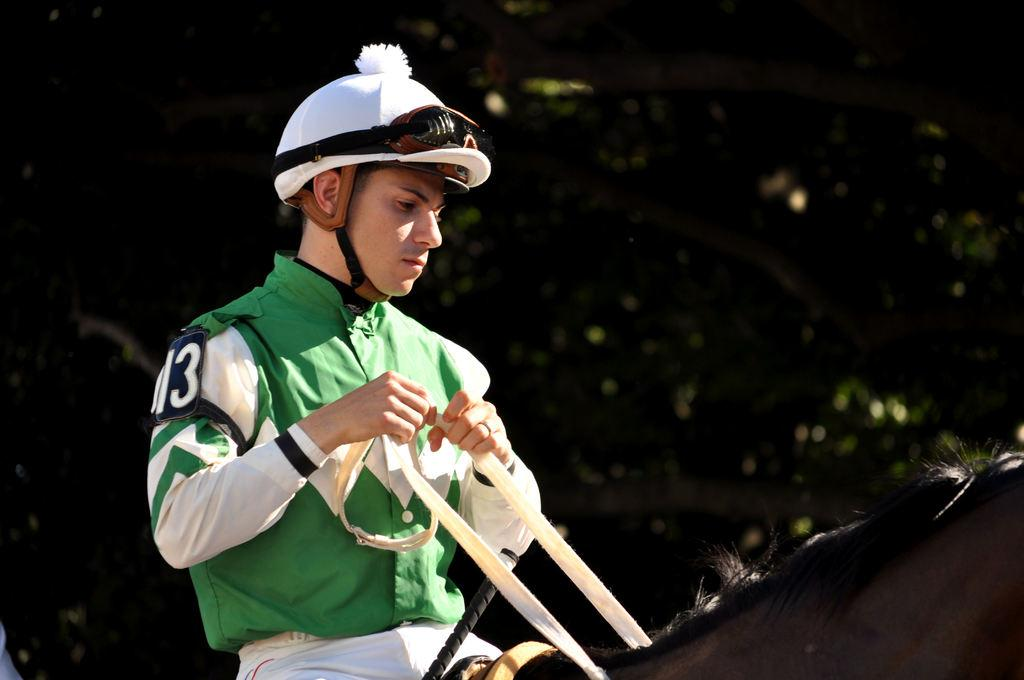What is the main subject of the image? The main subject of the image is a man. What is the man wearing in the image? The man is wearing a green shirt and a white helmet. What is the man doing in the image? The man is riding a horse. What can be seen in the background of the image? There are trees in the background of the image. What type of stem can be seen on the man's shirt in the image? There is no stem present on the man's shirt in the image; he is wearing a green shirt with no visible stem. 